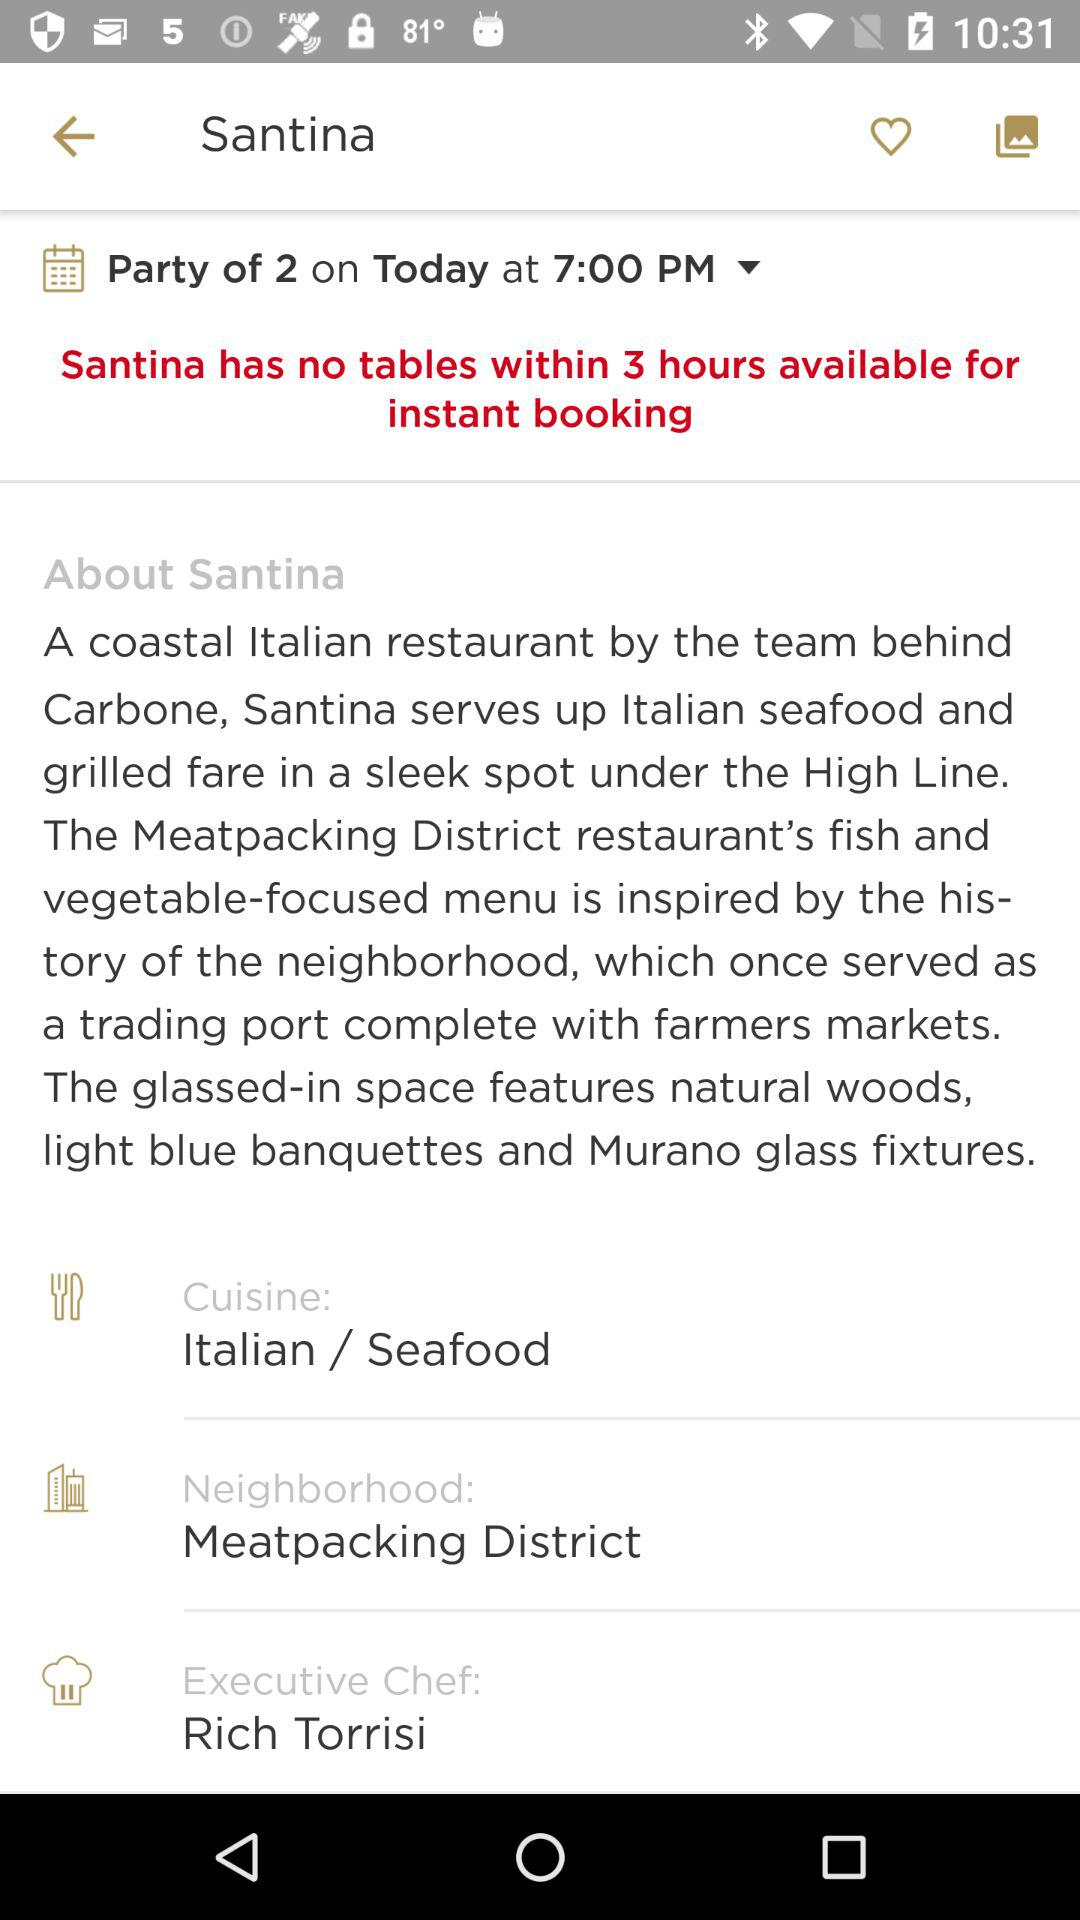For what date and time is the booking being done? The booking is being done for today at 7:00 p.m. 